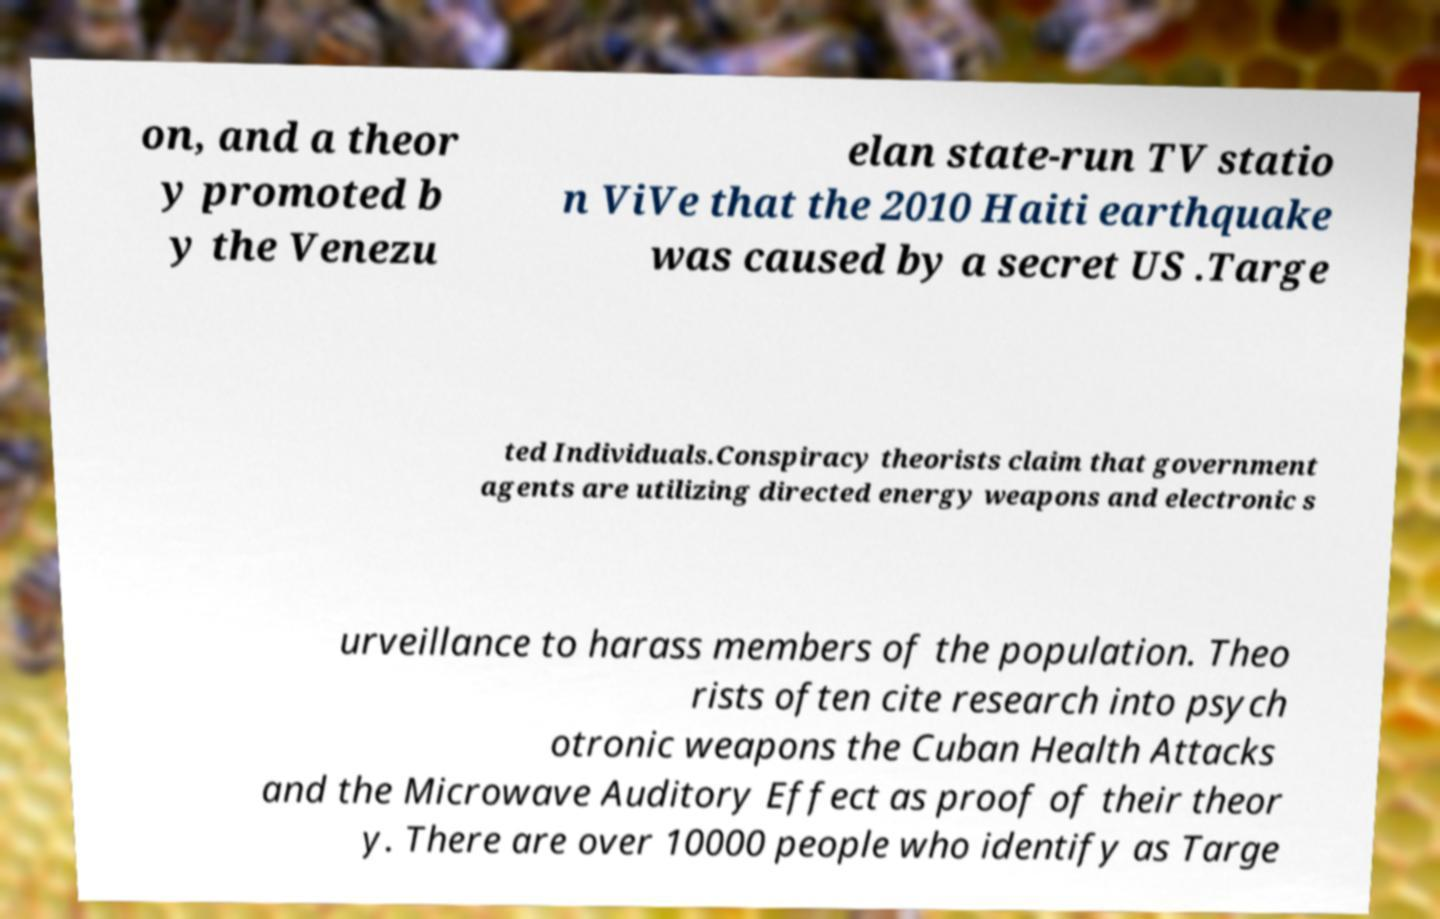Please read and relay the text visible in this image. What does it say? on, and a theor y promoted b y the Venezu elan state-run TV statio n ViVe that the 2010 Haiti earthquake was caused by a secret US .Targe ted Individuals.Conspiracy theorists claim that government agents are utilizing directed energy weapons and electronic s urveillance to harass members of the population. Theo rists often cite research into psych otronic weapons the Cuban Health Attacks and the Microwave Auditory Effect as proof of their theor y. There are over 10000 people who identify as Targe 